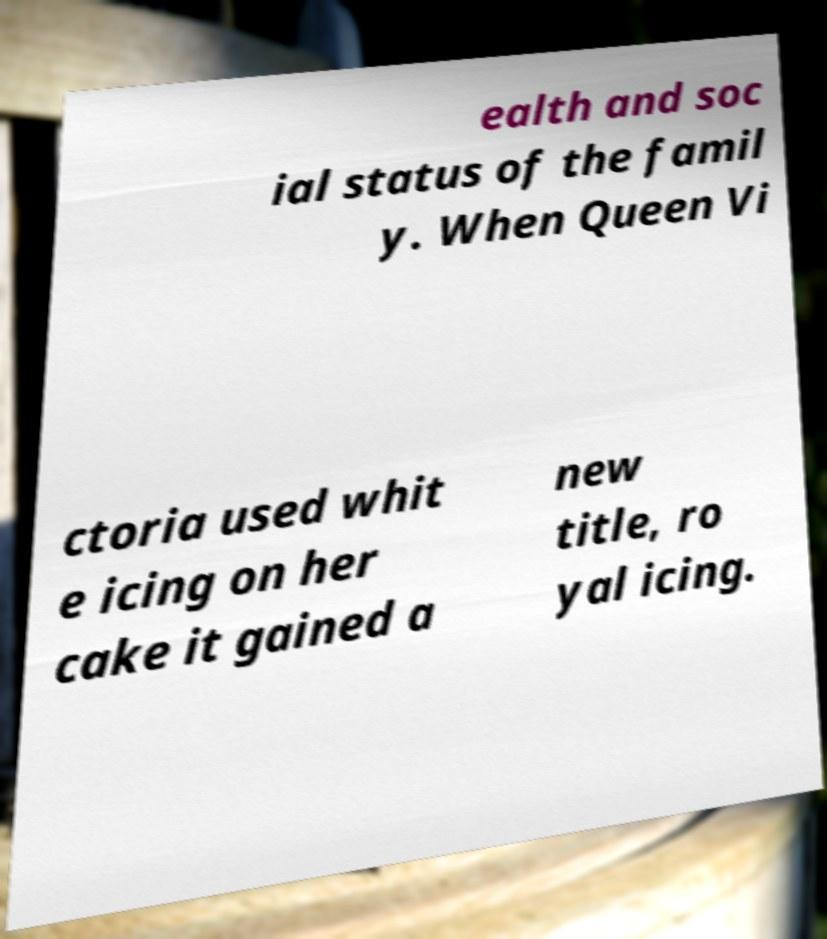Can you accurately transcribe the text from the provided image for me? ealth and soc ial status of the famil y. When Queen Vi ctoria used whit e icing on her cake it gained a new title, ro yal icing. 